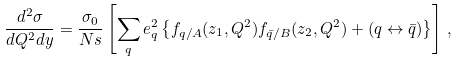Convert formula to latex. <formula><loc_0><loc_0><loc_500><loc_500>\frac { d ^ { 2 } \sigma } { d Q ^ { 2 } d y } = \frac { \sigma _ { 0 } } { N s } \left [ \sum _ { q } e _ { q } ^ { 2 } \left \{ f _ { q / A } ( z _ { 1 } , Q ^ { 2 } ) f _ { \bar { q } / B } ( z _ { 2 } , Q ^ { 2 } ) + ( q \leftrightarrow \bar { q } ) \right \} \right ] \, ,</formula> 